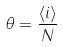Convert formula to latex. <formula><loc_0><loc_0><loc_500><loc_500>\theta = \frac { \langle i \rangle } { N }</formula> 